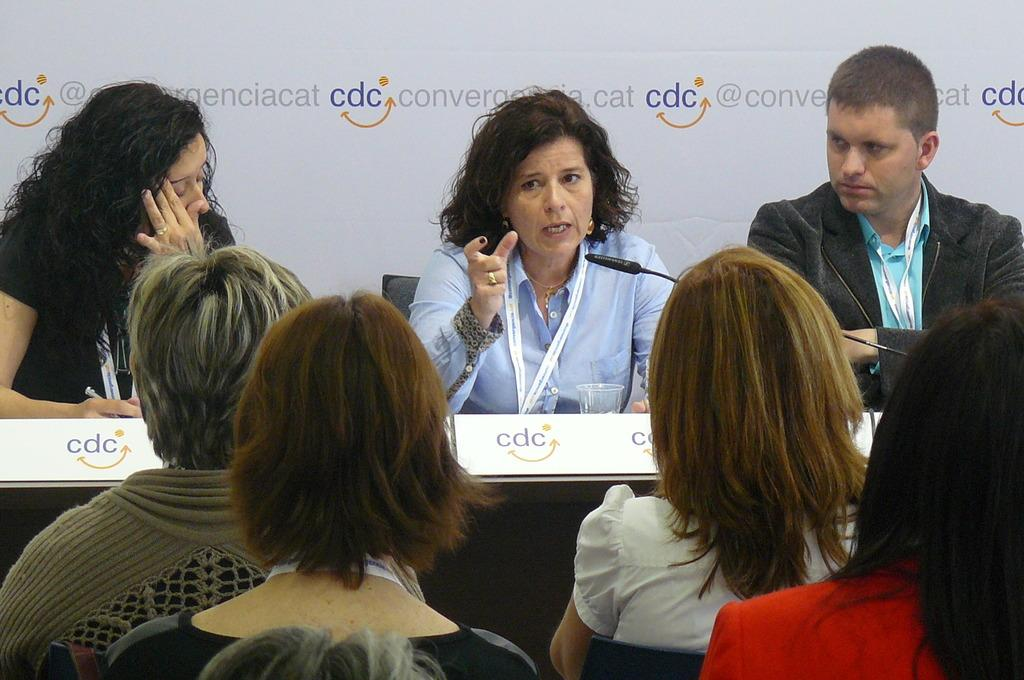What are the people in the image doing? The people in the image are sitting. What object is present that is typically used for amplifying sound? There is a microphone (mic) in the image. What object is present that is typically used for holding liquids? There is a glass in the image. What object is present that is typically used for displaying information or instructions? There is a board in the image. What can be seen in the background of the image? There is a white banner in the background. What is written on the banner? Something is written on the banner. What type of treatment is being administered to the people in the image? There is no indication of any treatment being administered to the people in the image. What is the bit used for in the image? There is no bit present in the image. What type of ink is used to write on the banner? There is no information about the type of ink used to write on the banner in the image. 